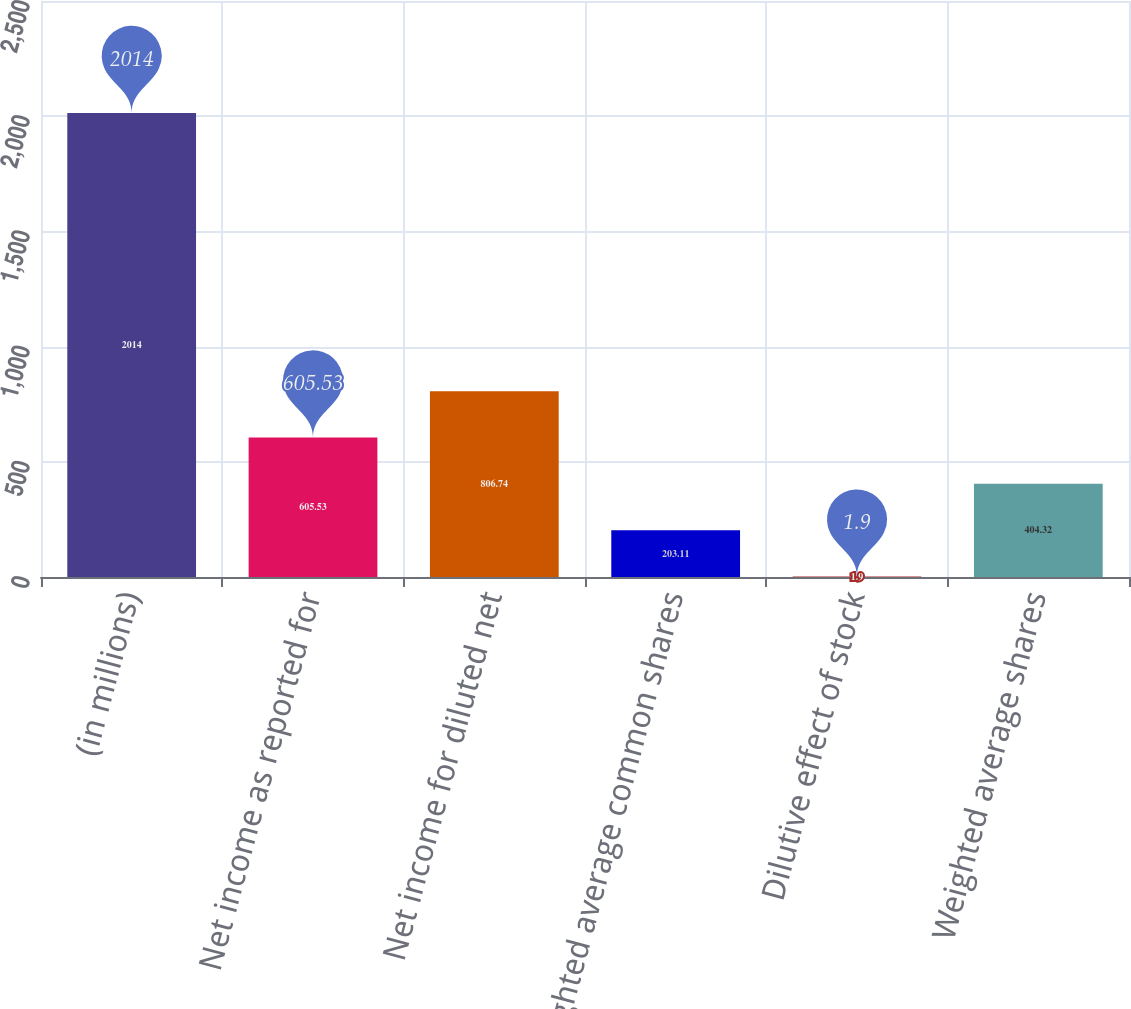<chart> <loc_0><loc_0><loc_500><loc_500><bar_chart><fcel>(in millions)<fcel>Net income as reported for<fcel>Net income for diluted net<fcel>Weighted average common shares<fcel>Dilutive effect of stock<fcel>Weighted average shares<nl><fcel>2014<fcel>605.53<fcel>806.74<fcel>203.11<fcel>1.9<fcel>404.32<nl></chart> 